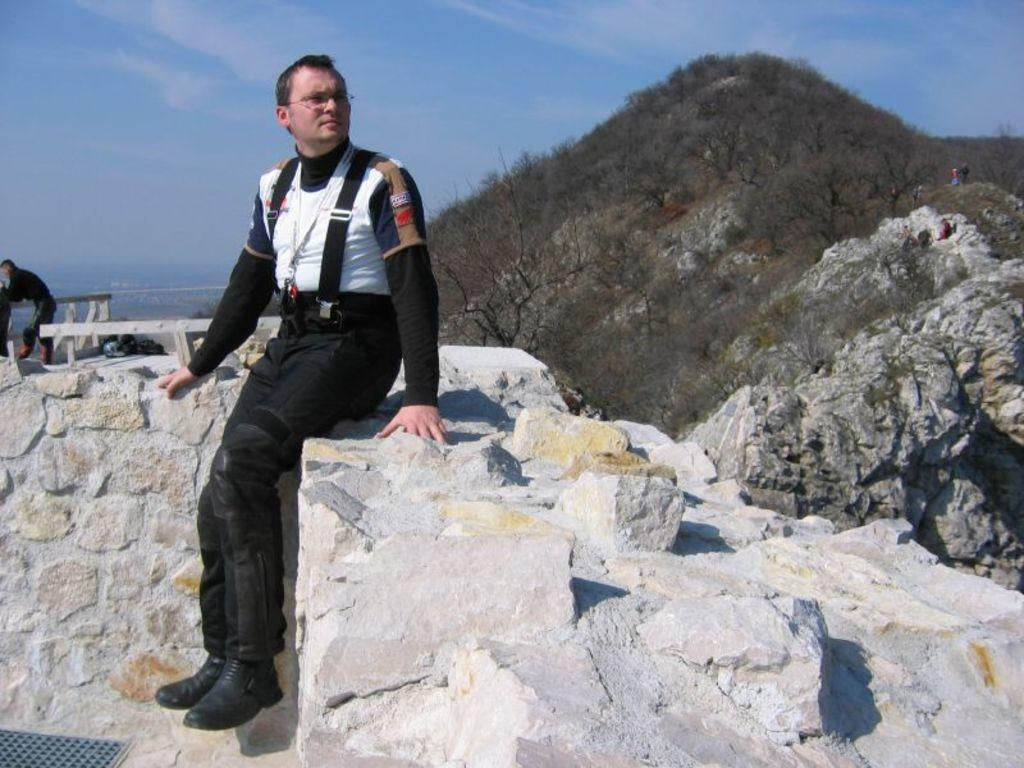Who is present in the image? There is a man in the image. What is the man wearing? The man is wearing spectacles. What type of natural environment can be seen in the image? There are trees and a mountain in the image. What is visible in the background of the image? The sky is visible in the background of the image. What type of crown can be seen on the man's head in the image? There is no crown present on the man's head in the image. Is the image taken during winter, given the presence of snow on the mountain? The facts provided do not mention snow on the mountain, so it cannot be determined if the image was taken during winter. 